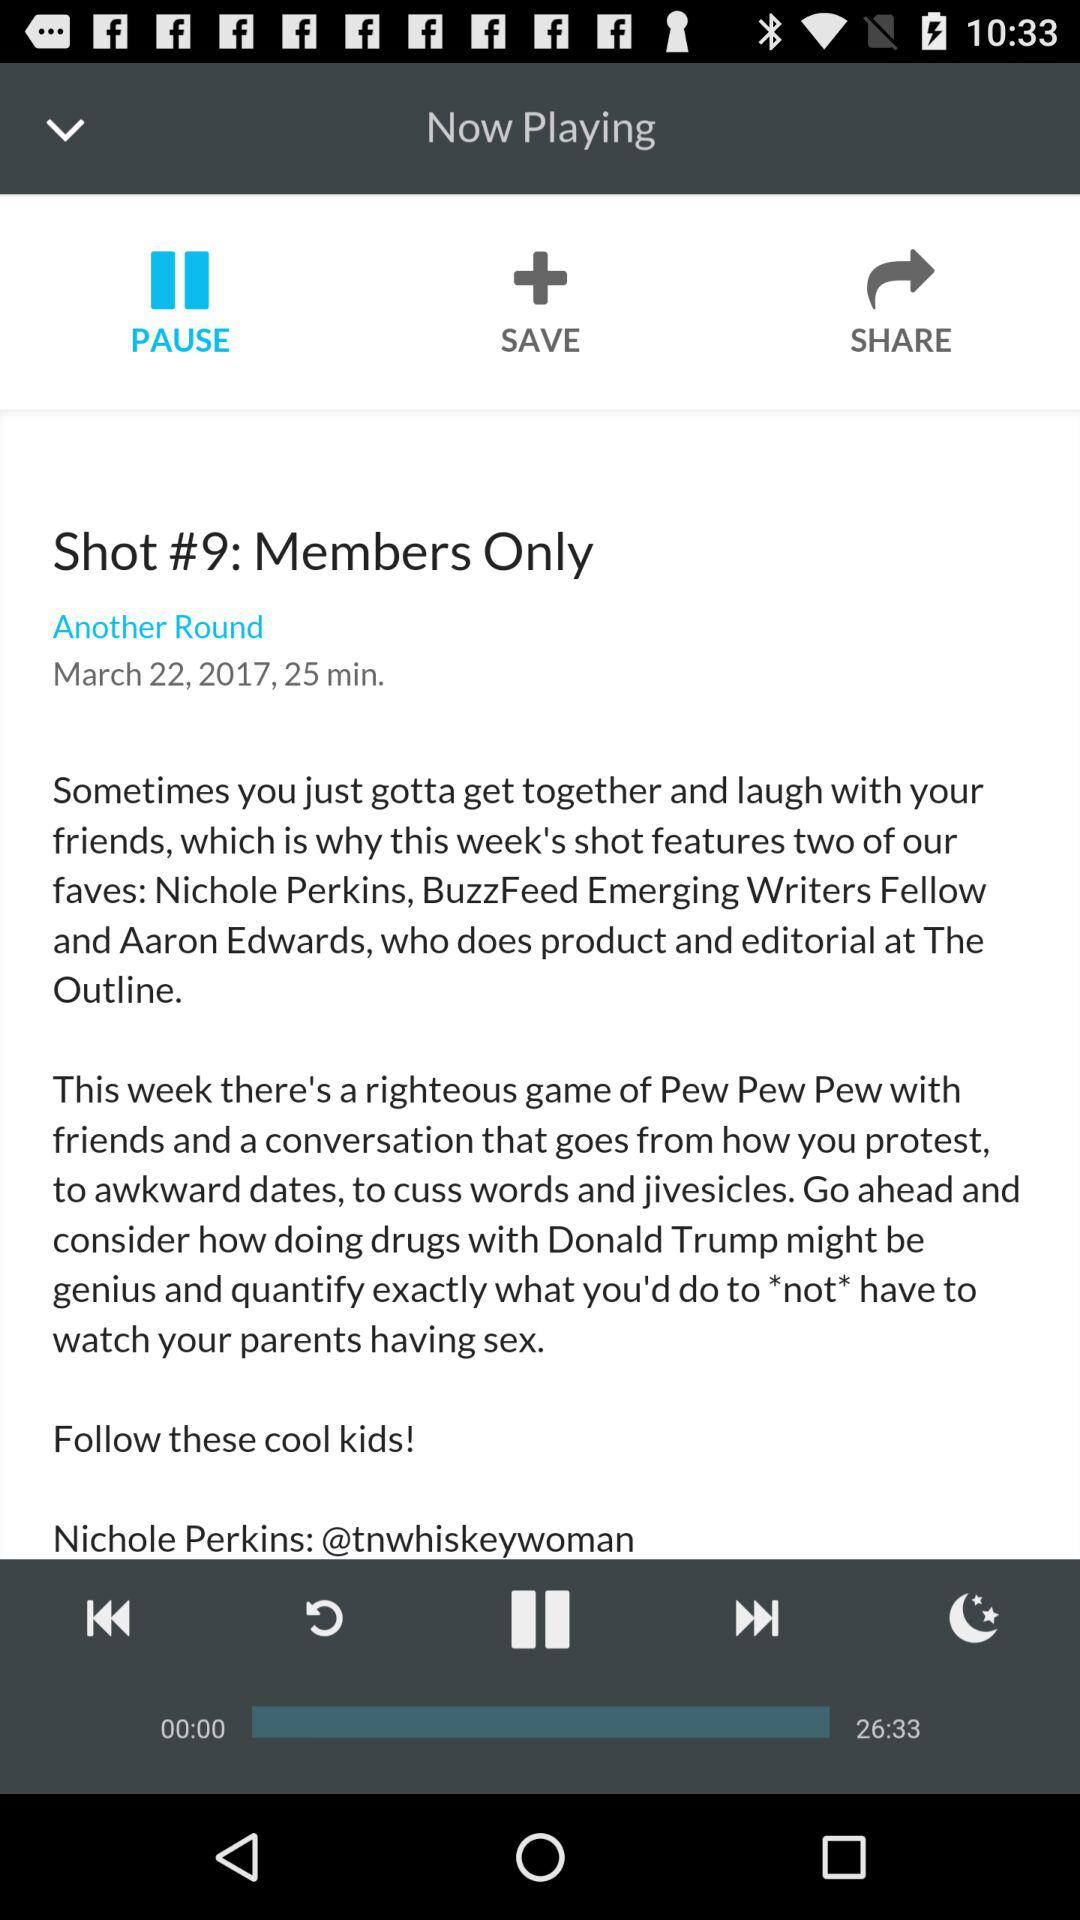What is the title? The title is "Shot #9: Members Only". 